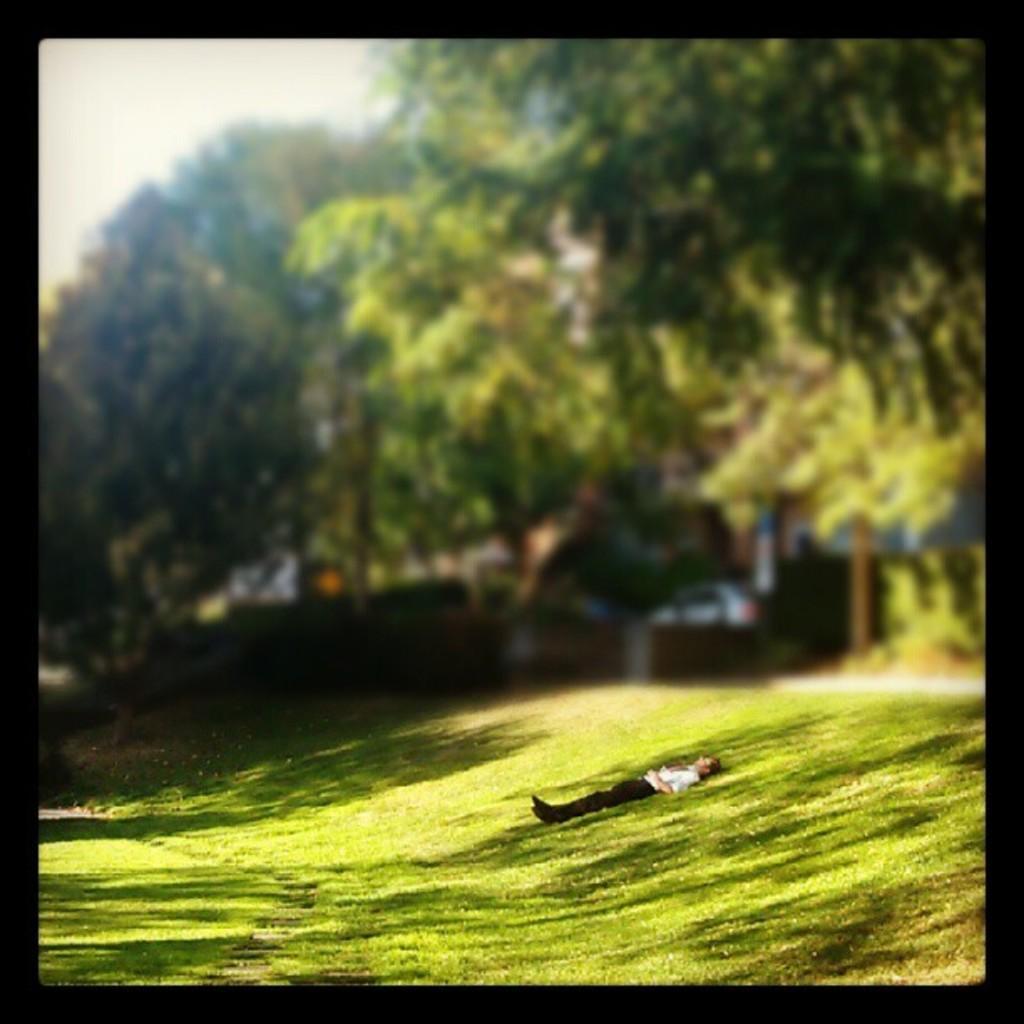In one or two sentences, can you explain what this image depicts? This looks like an edited image. I can see a person laying on the grass. These are the trees. I think this is a vehicle. 